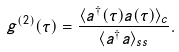Convert formula to latex. <formula><loc_0><loc_0><loc_500><loc_500>g ^ { ( 2 ) } ( \tau ) = \frac { \langle a ^ { \dagger } ( \tau ) a ( \tau ) \rangle _ { c } } { \langle a ^ { \dagger } a \rangle _ { s s } } .</formula> 